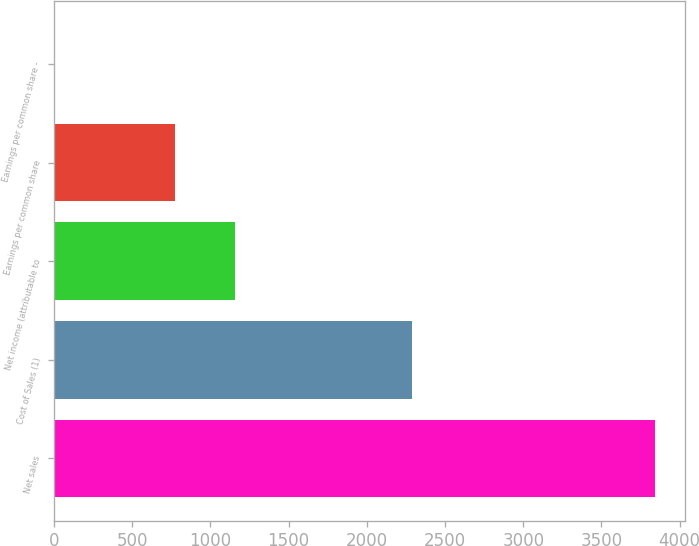Convert chart to OTSL. <chart><loc_0><loc_0><loc_500><loc_500><bar_chart><fcel>Net sales<fcel>Cost of Sales (1)<fcel>Net income (attributable to<fcel>Earnings per common share<fcel>Earnings per common share -<nl><fcel>3845<fcel>2288<fcel>1154.86<fcel>770.56<fcel>1.96<nl></chart> 